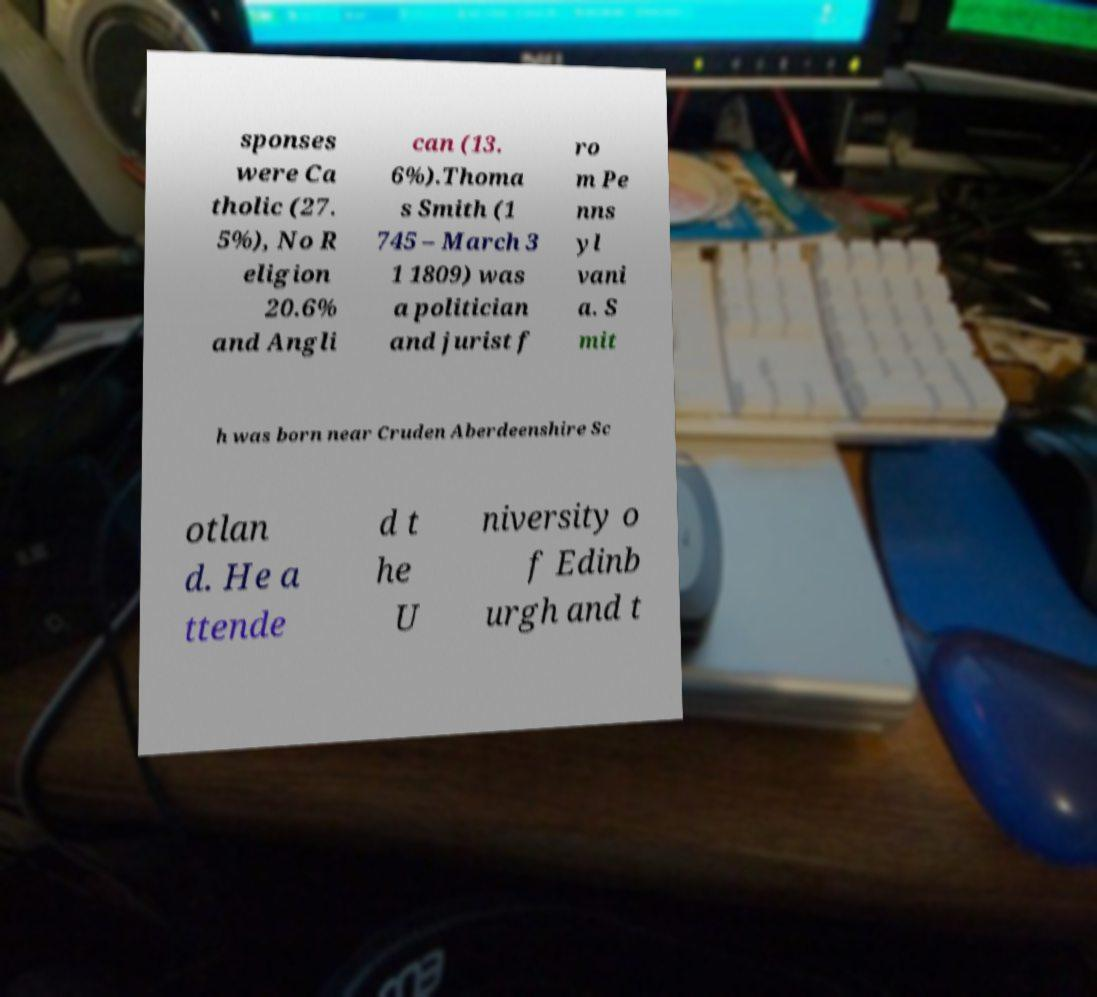Could you extract and type out the text from this image? sponses were Ca tholic (27. 5%), No R eligion 20.6% and Angli can (13. 6%).Thoma s Smith (1 745 – March 3 1 1809) was a politician and jurist f ro m Pe nns yl vani a. S mit h was born near Cruden Aberdeenshire Sc otlan d. He a ttende d t he U niversity o f Edinb urgh and t 